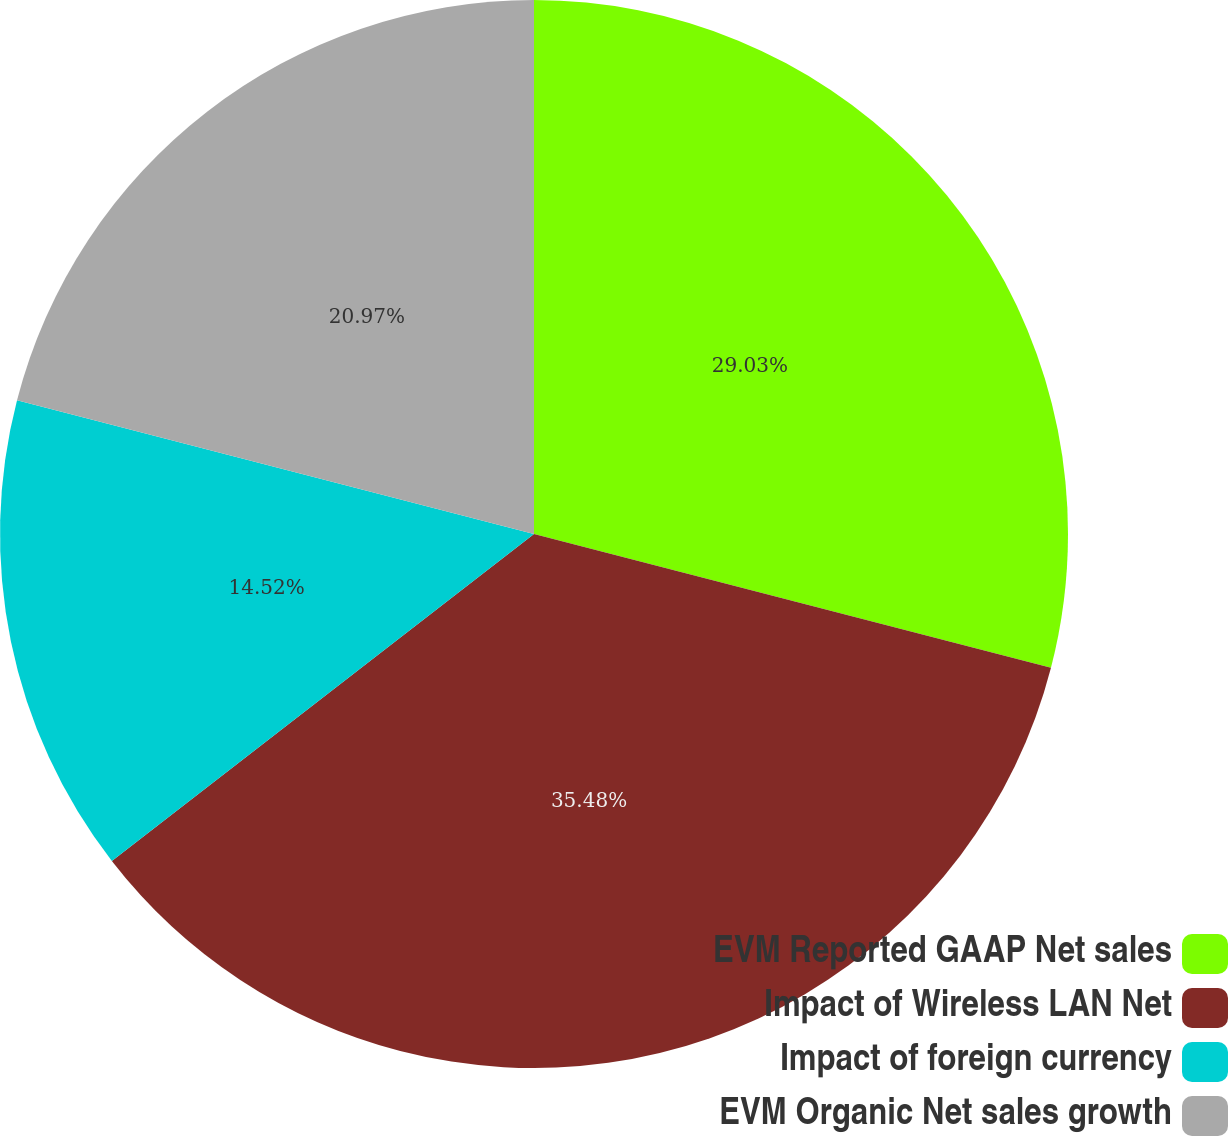Convert chart. <chart><loc_0><loc_0><loc_500><loc_500><pie_chart><fcel>EVM Reported GAAP Net sales<fcel>Impact of Wireless LAN Net<fcel>Impact of foreign currency<fcel>EVM Organic Net sales growth<nl><fcel>29.03%<fcel>35.48%<fcel>14.52%<fcel>20.97%<nl></chart> 